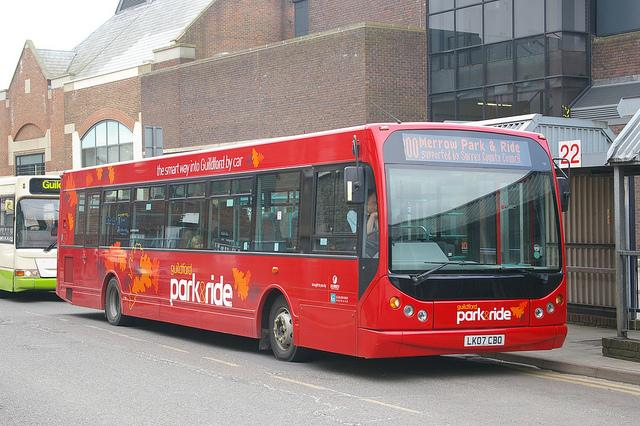What type of transportation is shown? Please explain your reasoning. road. Buses are parked in the street. buses are driven on roads. 